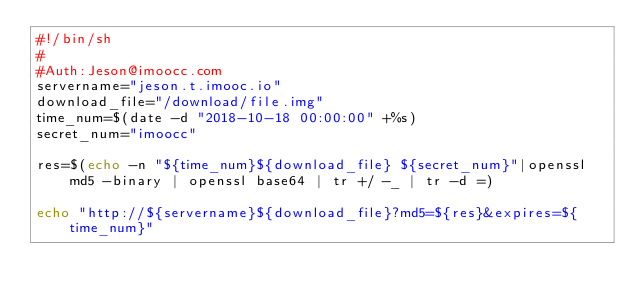Convert code to text. <code><loc_0><loc_0><loc_500><loc_500><_Bash_>#!/bin/sh
#
#Auth:Jeson@imoocc.com
servername="jeson.t.imooc.io"
download_file="/download/file.img"
time_num=$(date -d "2018-10-18 00:00:00" +%s)
secret_num="imoocc"

res=$(echo -n "${time_num}${download_file} ${secret_num}"|openssl md5 -binary | openssl base64 | tr +/ -_ | tr -d =)

echo "http://${servername}${download_file}?md5=${res}&expires=${time_num}"
</code> 